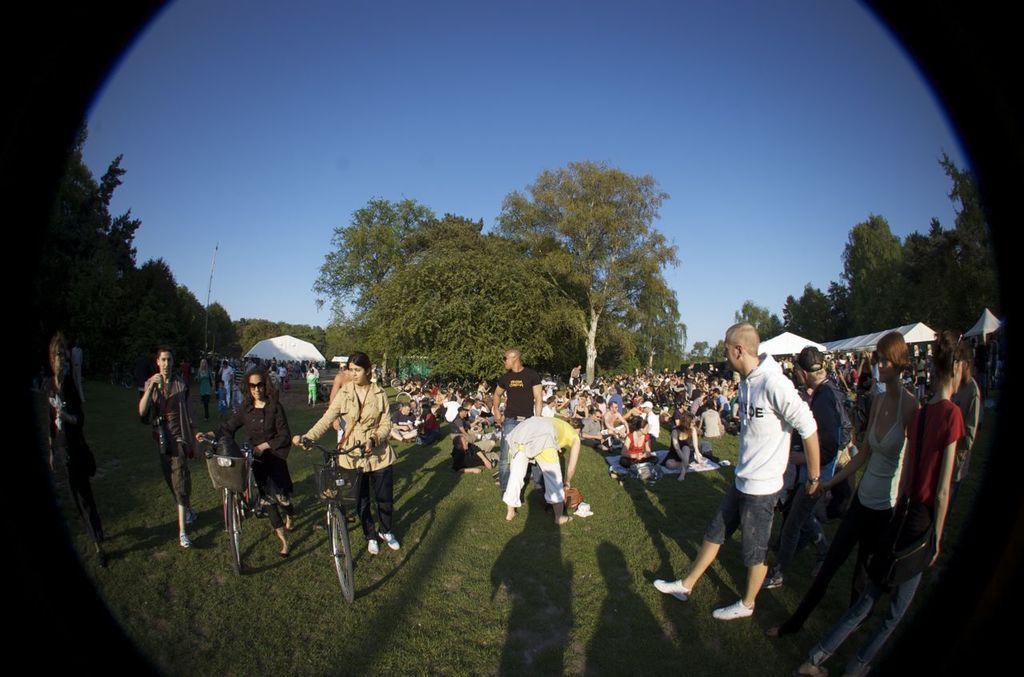Describe this image in one or two sentences. In front of the picture, we see two women are holding the bicycles. Beside them, we see two people are standing. Behind them, we see people are sitting on the ground and they are practicing the yoga. On the right side, we see people are standing. There are trees and a pole in the background. We even see the tents which are white in color. At the top, we see the sky, which is blue in color. At the bottom, we see the grass. This might be an edited image. 